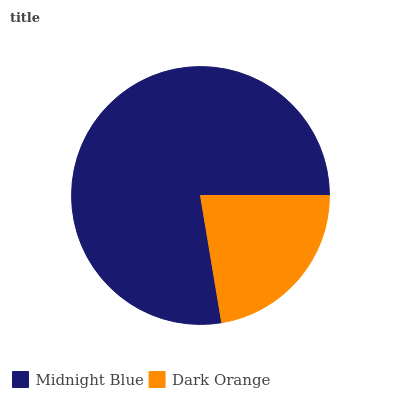Is Dark Orange the minimum?
Answer yes or no. Yes. Is Midnight Blue the maximum?
Answer yes or no. Yes. Is Dark Orange the maximum?
Answer yes or no. No. Is Midnight Blue greater than Dark Orange?
Answer yes or no. Yes. Is Dark Orange less than Midnight Blue?
Answer yes or no. Yes. Is Dark Orange greater than Midnight Blue?
Answer yes or no. No. Is Midnight Blue less than Dark Orange?
Answer yes or no. No. Is Midnight Blue the high median?
Answer yes or no. Yes. Is Dark Orange the low median?
Answer yes or no. Yes. Is Dark Orange the high median?
Answer yes or no. No. Is Midnight Blue the low median?
Answer yes or no. No. 